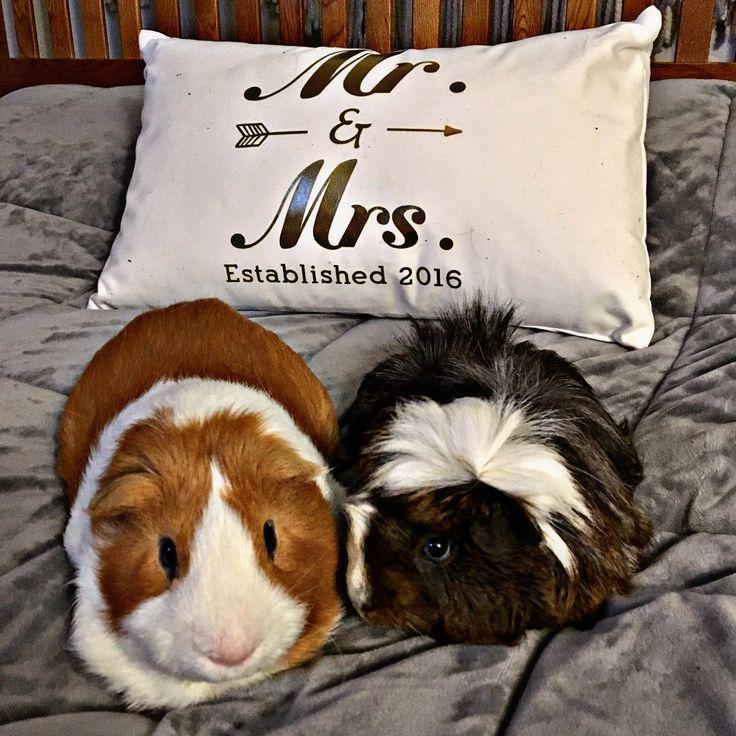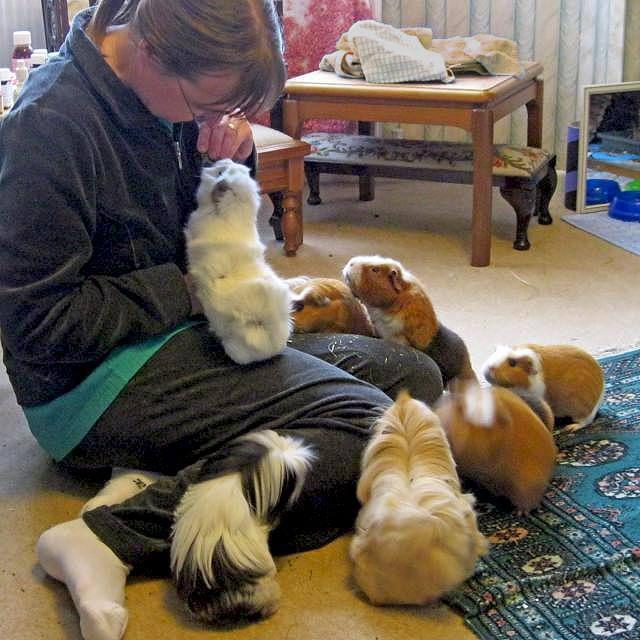The first image is the image on the left, the second image is the image on the right. For the images shown, is this caption "At least one image features at least six guinea pigs." true? Answer yes or no. Yes. The first image is the image on the left, the second image is the image on the right. Analyze the images presented: Is the assertion "An image shows a guinea pig having some type of snack." valid? Answer yes or no. No. The first image is the image on the left, the second image is the image on the right. Analyze the images presented: Is the assertion "There are no more than 4 guinea pigs." valid? Answer yes or no. No. The first image is the image on the left, the second image is the image on the right. Evaluate the accuracy of this statement regarding the images: "There are exactly two animals in the image on the left.". Is it true? Answer yes or no. Yes. 